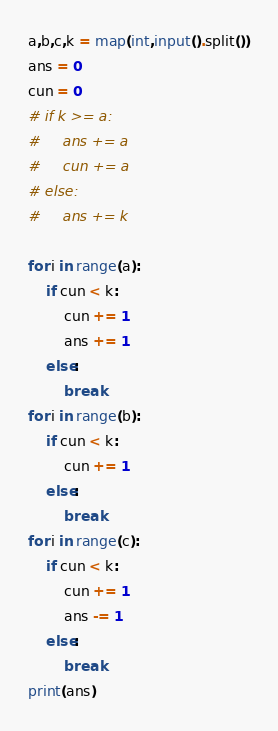<code> <loc_0><loc_0><loc_500><loc_500><_Python_>a,b,c,k = map(int,input().split())
ans = 0
cun = 0
# if k >= a:
#     ans += a
#     cun += a
# else:
#     ans += k

for i in range(a):
    if cun < k:
        cun += 1
        ans += 1
    else:
        break
for i in range(b):
    if cun < k:
        cun += 1
    else:
        break
for i in range(c):
    if cun < k:
        cun += 1
        ans -= 1
    else:
        break
print(ans)
</code> 